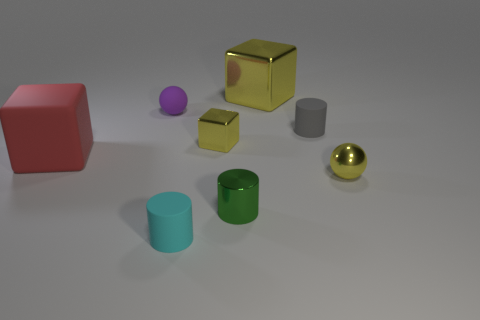How many cylinders are either large metal things or gray rubber objects?
Provide a succinct answer. 1. There is a big block to the left of the green metallic object; does it have the same color as the metallic cylinder?
Your response must be concise. No. There is a small yellow thing on the left side of the small sphere that is on the right side of the tiny cyan rubber cylinder that is in front of the tiny shiny cylinder; what is its material?
Provide a succinct answer. Metal. Is the purple rubber object the same size as the cyan cylinder?
Your answer should be very brief. Yes. There is a big metal object; is it the same color as the cylinder behind the large matte thing?
Offer a terse response. No. There is a small gray object that is made of the same material as the large red object; what shape is it?
Ensure brevity in your answer.  Cylinder. There is a tiny yellow shiny thing right of the small green metal cylinder; does it have the same shape as the large shiny thing?
Provide a succinct answer. No. What size is the metal object that is in front of the tiny ball that is right of the tiny gray rubber cylinder?
Ensure brevity in your answer.  Small. What color is the sphere that is the same material as the large red block?
Provide a succinct answer. Purple. How many other yellow balls have the same size as the shiny ball?
Give a very brief answer. 0. 